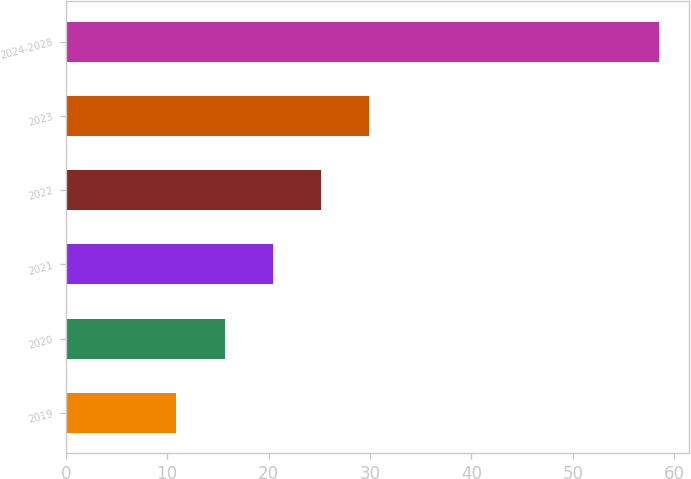Convert chart. <chart><loc_0><loc_0><loc_500><loc_500><bar_chart><fcel>2019<fcel>2020<fcel>2021<fcel>2022<fcel>2023<fcel>2024-2028<nl><fcel>10.9<fcel>15.66<fcel>20.42<fcel>25.18<fcel>29.94<fcel>58.5<nl></chart> 